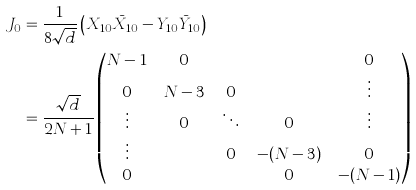<formula> <loc_0><loc_0><loc_500><loc_500>J _ { 0 } & = \frac { 1 } { 8 \sqrt { d } } \left ( X _ { 1 0 } \bar { X } _ { 1 0 } - Y _ { 1 0 } \bar { Y } _ { 1 0 } \right ) \\ & = \frac { \sqrt { d } } { 2 N + 1 } \begin{pmatrix} N - 1 & 0 & \cdots & \cdots & 0 \\ 0 & N - 3 & 0 & \cdots & \vdots \\ \vdots & 0 & \ddots & 0 & \vdots \\ \vdots & \cdots & 0 & - ( N - 3 ) & 0 \\ 0 & \cdots & \cdots & 0 & - ( N - 1 ) \end{pmatrix}</formula> 